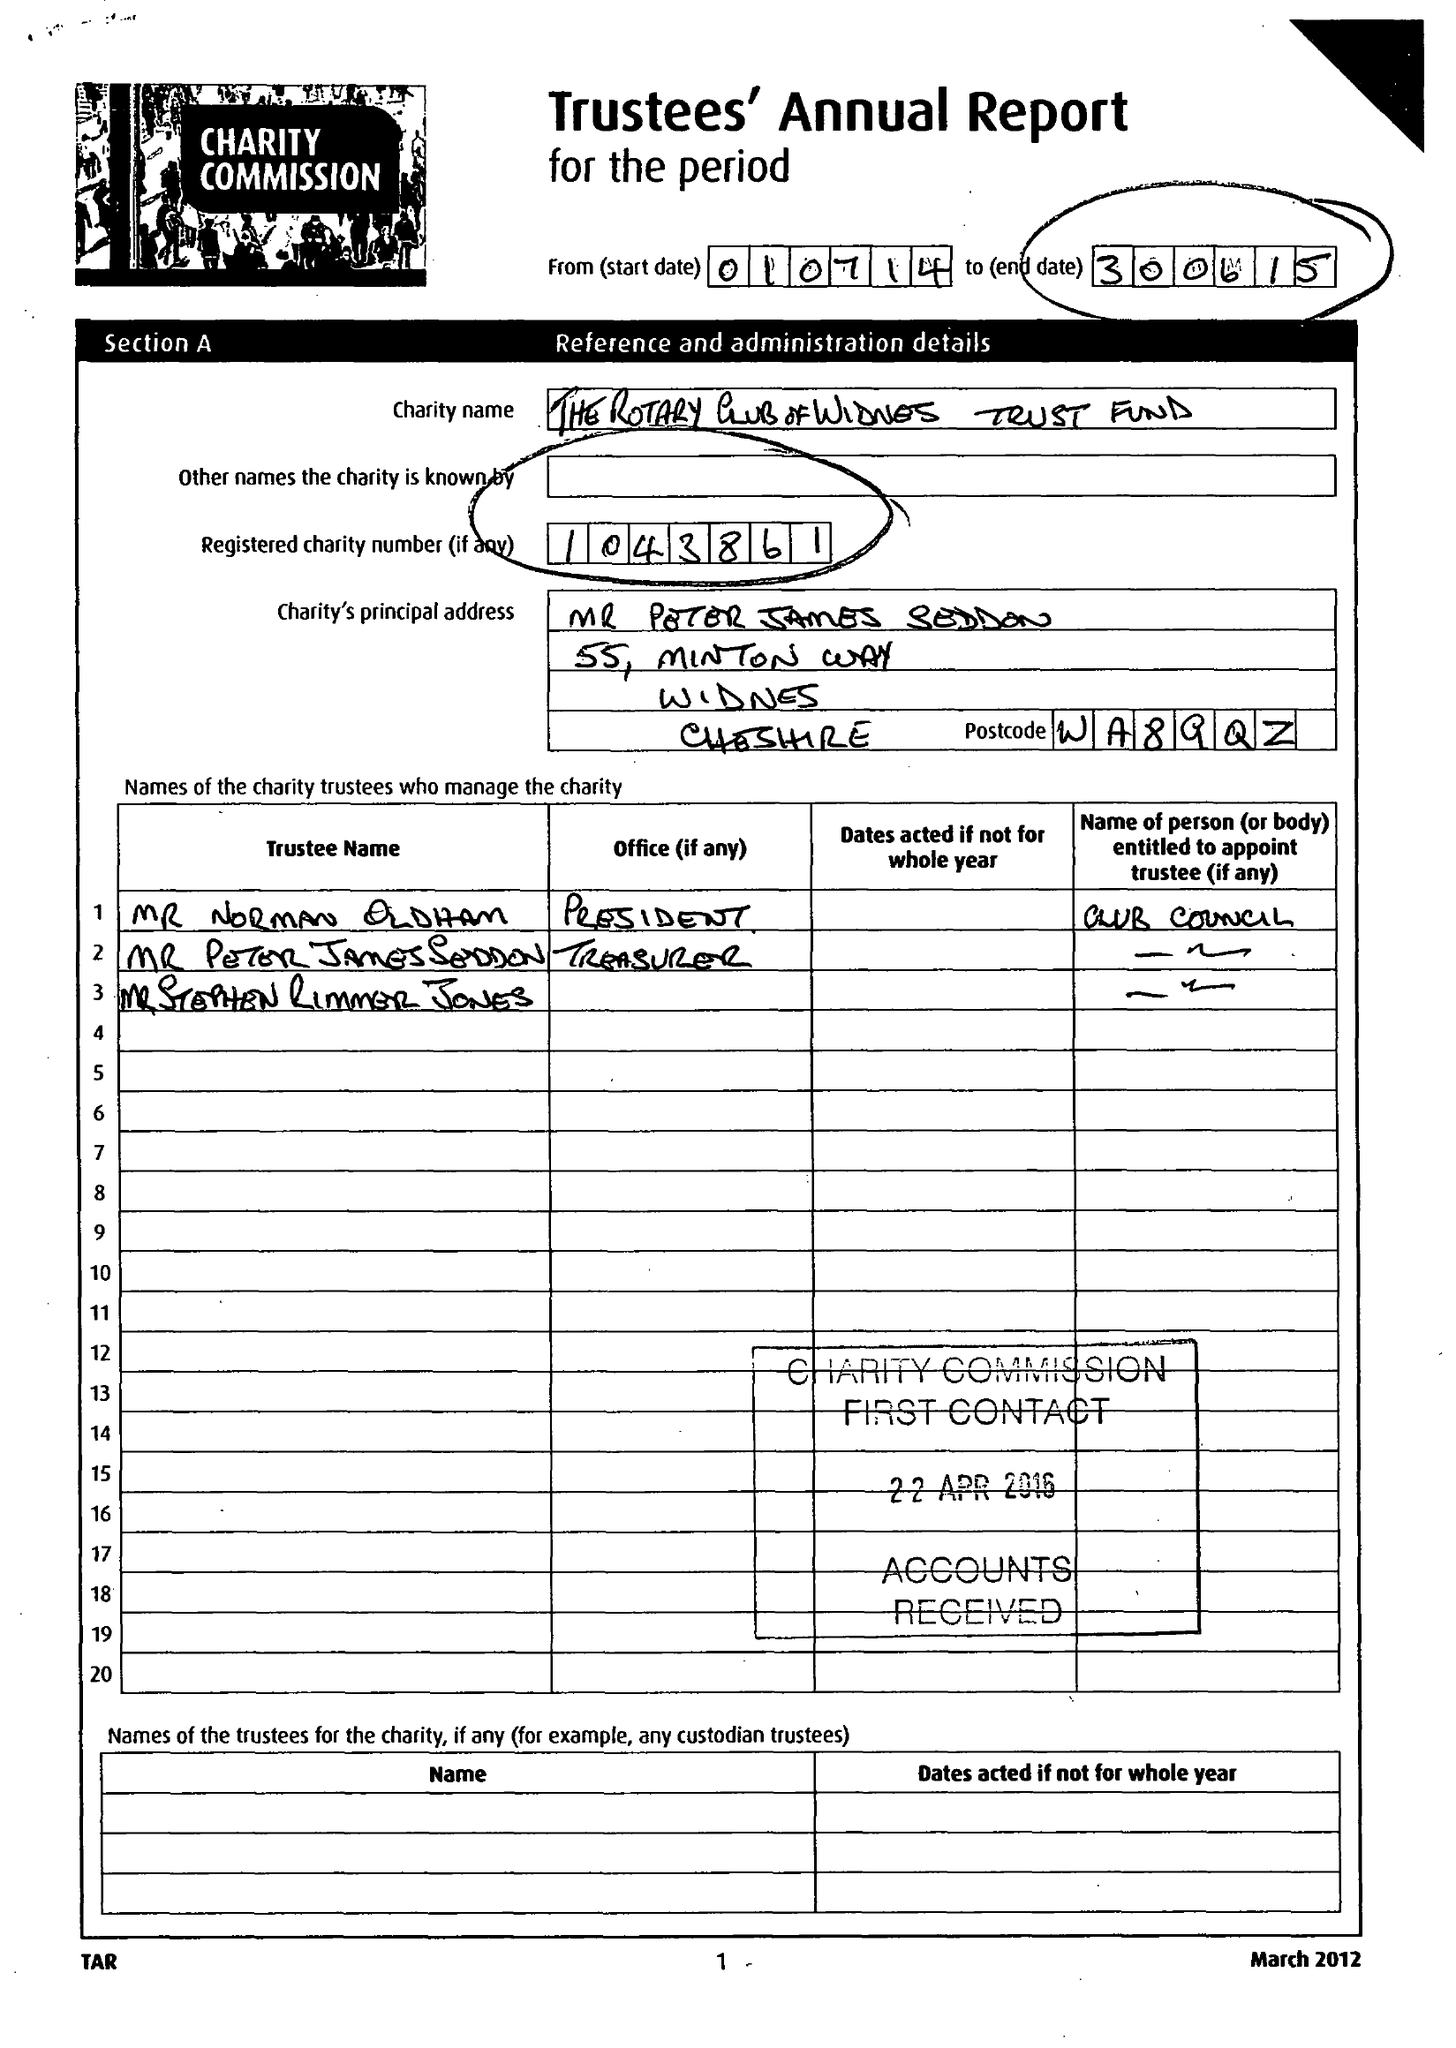What is the value for the address__street_line?
Answer the question using a single word or phrase. 5 NEW BARNET 